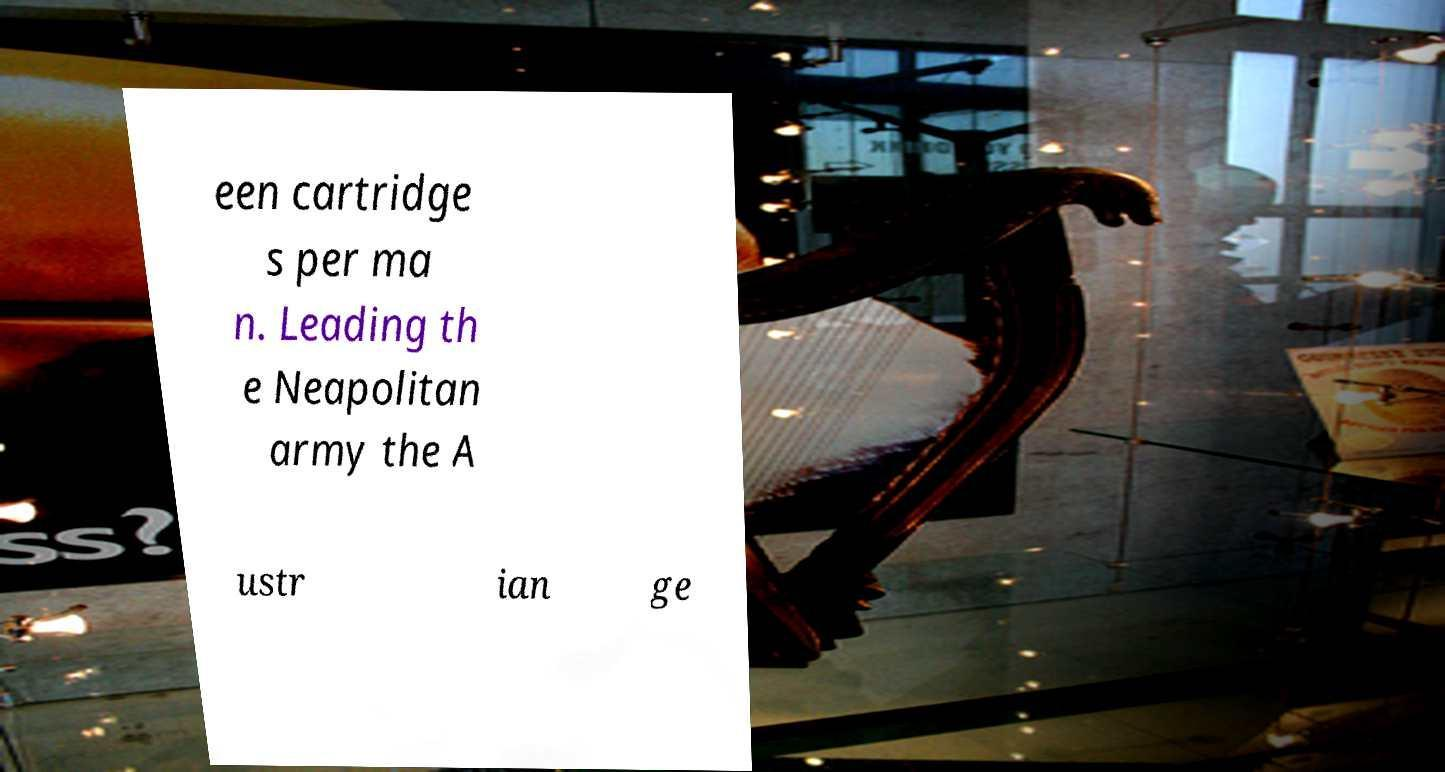Please identify and transcribe the text found in this image. een cartridge s per ma n. Leading th e Neapolitan army the A ustr ian ge 